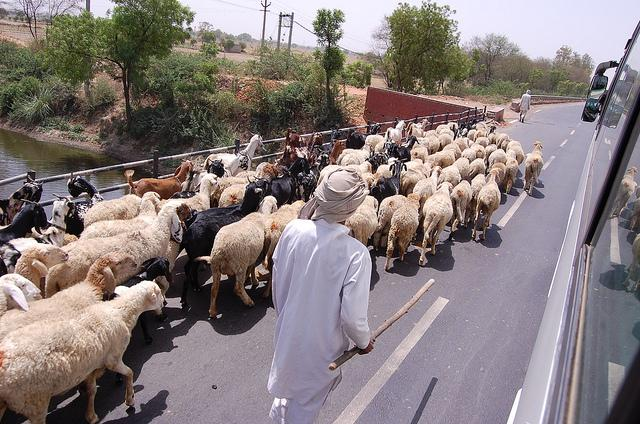What side of the rest is usually best for passing? Please explain your reasoning. left. We drive on the right and pass on the left. 